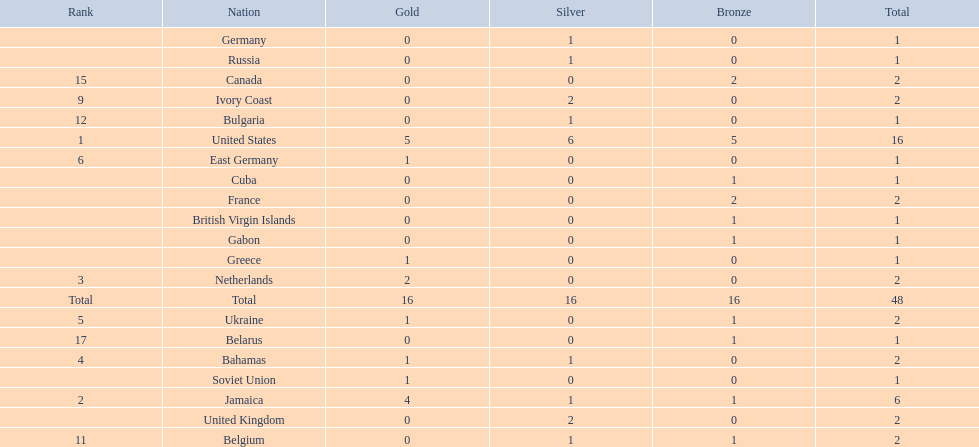Which countries won at least 3 silver medals? United States. 